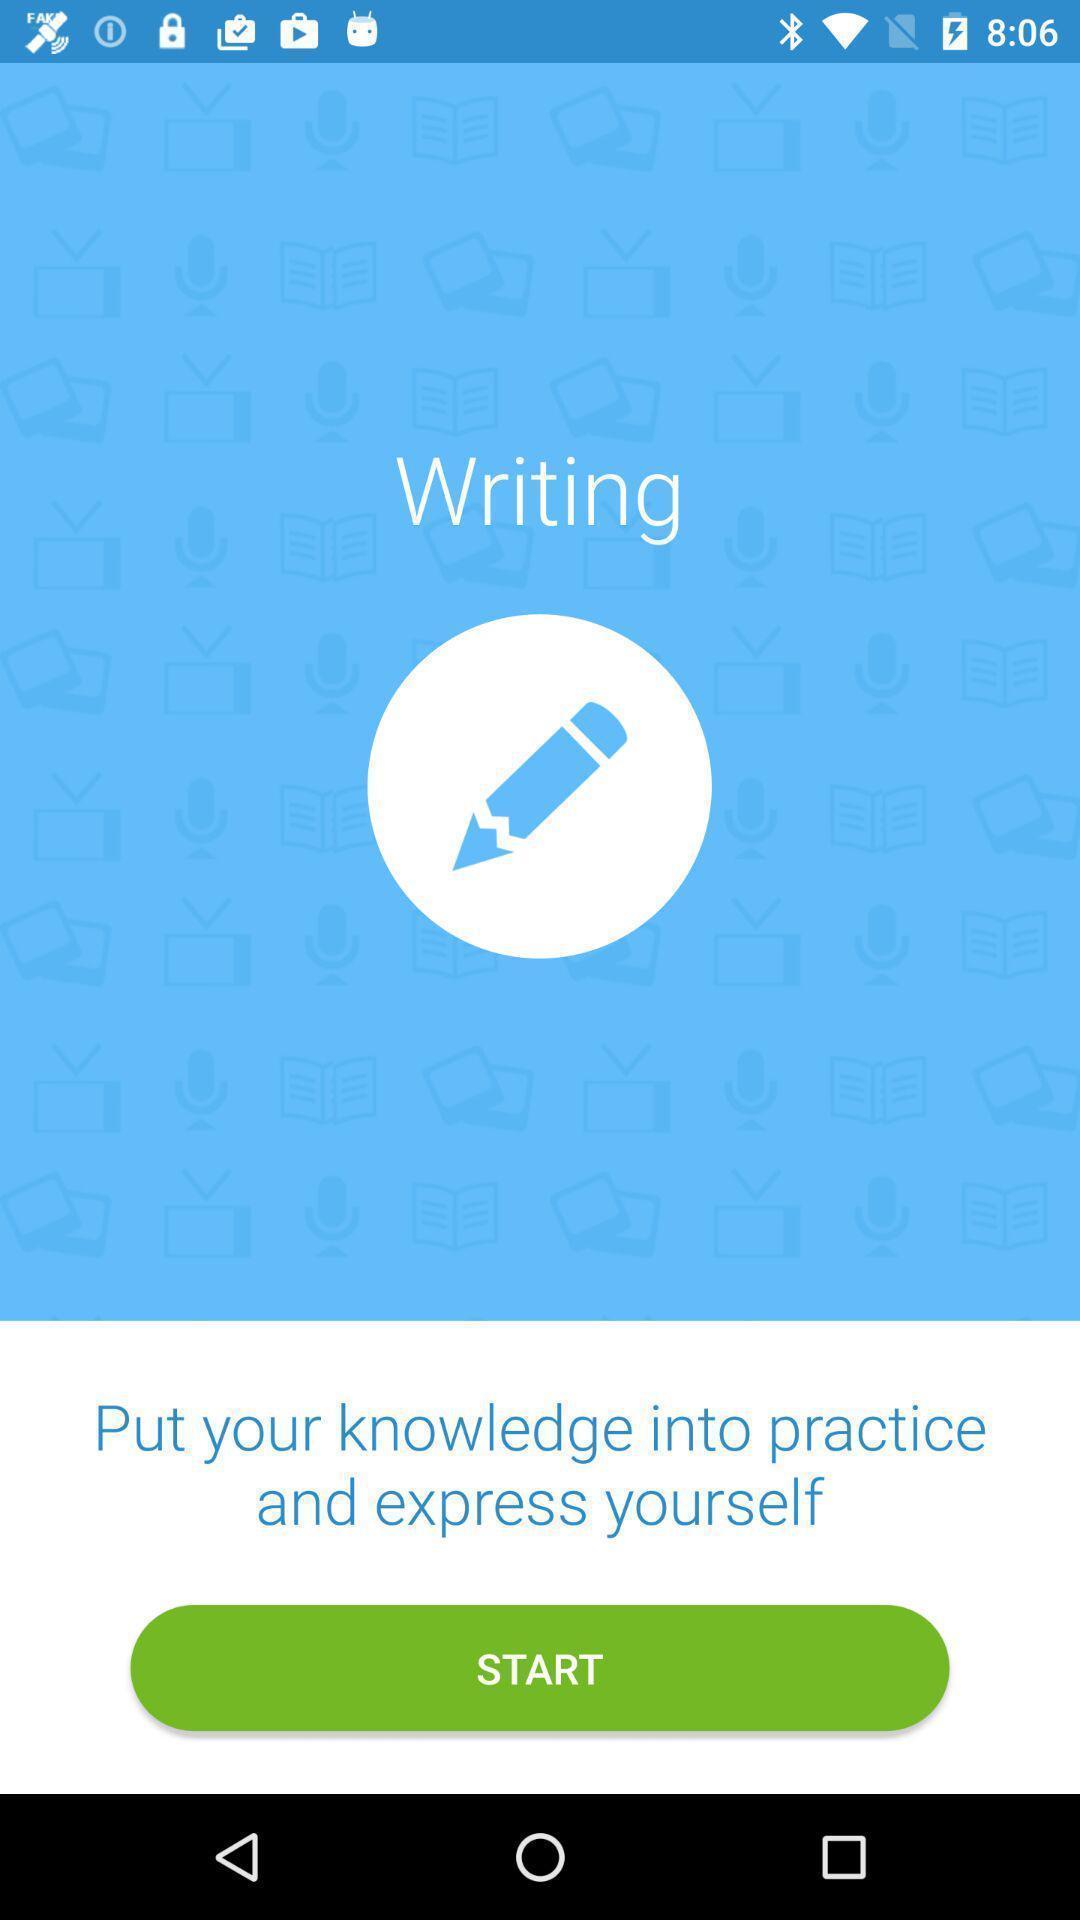Provide a textual representation of this image. Welcome page. 